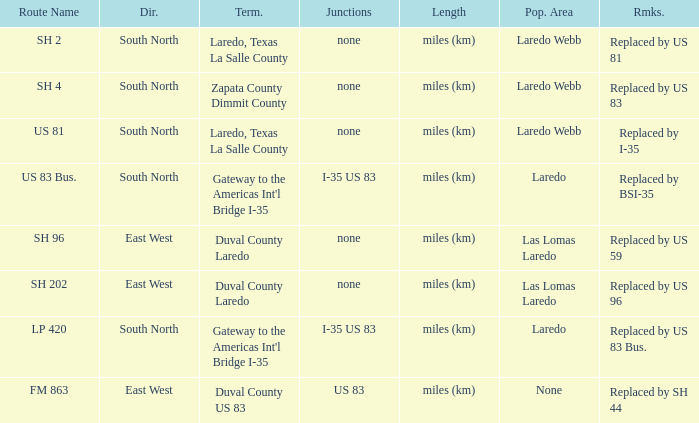How many termini are there that have "east west" listed in their direction section, "none" listed in their junction section, and have a route name of "sh 202"? 1.0. 